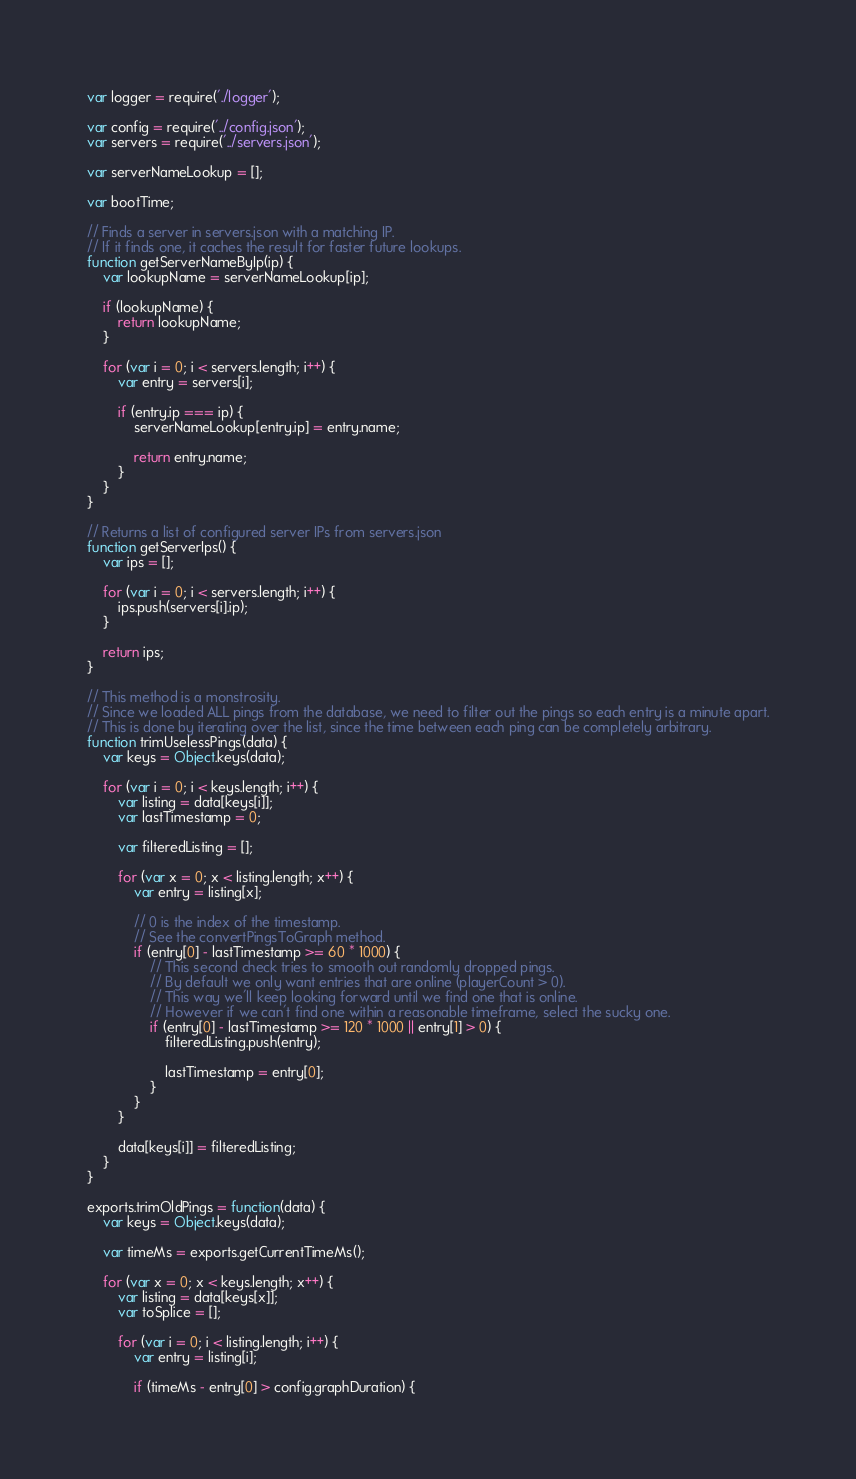Convert code to text. <code><loc_0><loc_0><loc_500><loc_500><_JavaScript_>var logger = require('./logger');

var config = require('../config.json');
var servers = require('../servers.json');

var serverNameLookup = [];

var bootTime;

// Finds a server in servers.json with a matching IP.
// If it finds one, it caches the result for faster future lookups.
function getServerNameByIp(ip) {
	var lookupName = serverNameLookup[ip];

	if (lookupName) {
		return lookupName;
	}

	for (var i = 0; i < servers.length; i++) {
		var entry = servers[i];

		if (entry.ip === ip) {
			serverNameLookup[entry.ip] = entry.name;

			return entry.name;
		}
	}
}

// Returns a list of configured server IPs from servers.json
function getServerIps() {
	var ips = [];

	for (var i = 0; i < servers.length; i++) {
		ips.push(servers[i].ip);
	}

	return ips;
}

// This method is a monstrosity.
// Since we loaded ALL pings from the database, we need to filter out the pings so each entry is a minute apart.
// This is done by iterating over the list, since the time between each ping can be completely arbitrary.
function trimUselessPings(data) {
	var keys = Object.keys(data);

	for (var i = 0; i < keys.length; i++) {
		var listing = data[keys[i]];
		var lastTimestamp = 0;

		var filteredListing = [];

		for (var x = 0; x < listing.length; x++) {
			var entry = listing[x];

			// 0 is the index of the timestamp.
			// See the convertPingsToGraph method.
			if (entry[0] - lastTimestamp >= 60 * 1000) {
				// This second check tries to smooth out randomly dropped pings.
				// By default we only want entries that are online (playerCount > 0).
				// This way we'll keep looking forward until we find one that is online.
				// However if we can't find one within a reasonable timeframe, select the sucky one.
				if (entry[0] - lastTimestamp >= 120 * 1000 || entry[1] > 0) {
					filteredListing.push(entry);

					lastTimestamp = entry[0];
				}
			}
		}

		data[keys[i]] = filteredListing;
	}
}

exports.trimOldPings = function(data) {
	var keys = Object.keys(data);

	var timeMs = exports.getCurrentTimeMs();

	for (var x = 0; x < keys.length; x++) {
		var listing = data[keys[x]];
		var toSplice = [];

		for (var i = 0; i < listing.length; i++) {
			var entry = listing[i];

			if (timeMs - entry[0] > config.graphDuration) {</code> 